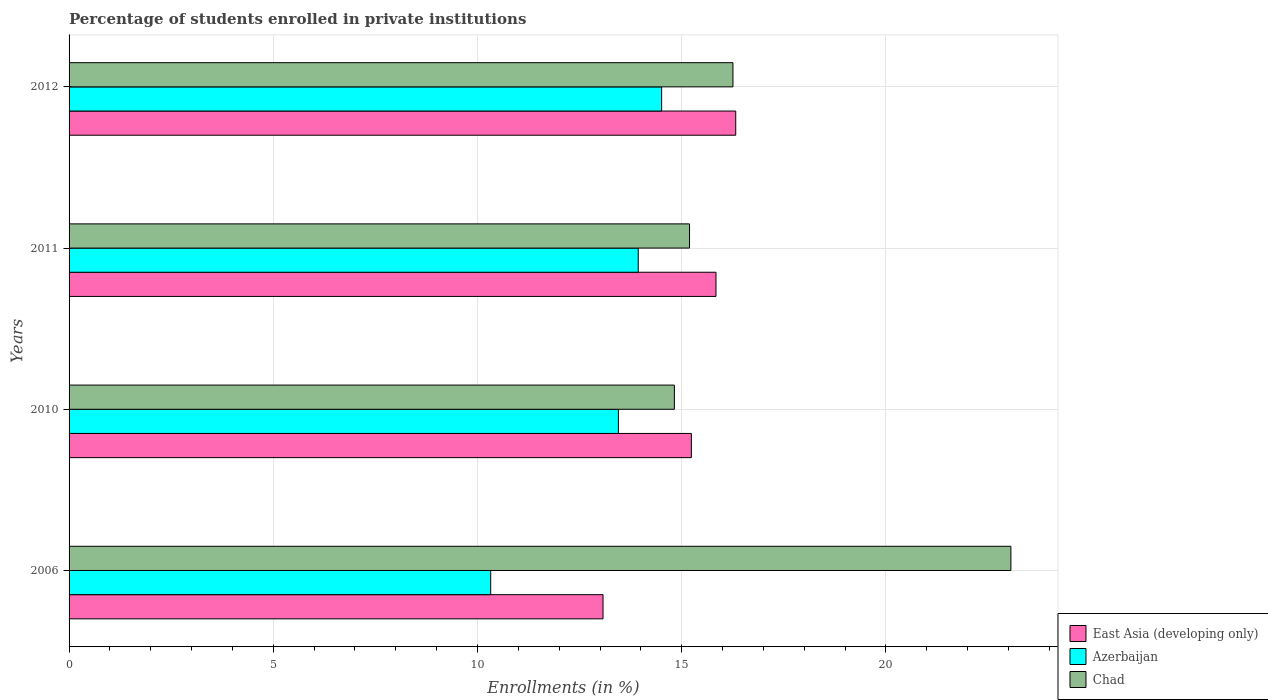How many different coloured bars are there?
Ensure brevity in your answer.  3. How many groups of bars are there?
Keep it short and to the point. 4. How many bars are there on the 2nd tick from the top?
Keep it short and to the point. 3. How many bars are there on the 2nd tick from the bottom?
Offer a terse response. 3. In how many cases, is the number of bars for a given year not equal to the number of legend labels?
Provide a short and direct response. 0. What is the percentage of trained teachers in Chad in 2010?
Provide a succinct answer. 14.82. Across all years, what is the maximum percentage of trained teachers in Azerbaijan?
Keep it short and to the point. 14.51. Across all years, what is the minimum percentage of trained teachers in East Asia (developing only)?
Your response must be concise. 13.07. In which year was the percentage of trained teachers in Azerbaijan maximum?
Offer a terse response. 2012. What is the total percentage of trained teachers in Chad in the graph?
Your response must be concise. 69.33. What is the difference between the percentage of trained teachers in Chad in 2011 and that in 2012?
Make the answer very short. -1.06. What is the difference between the percentage of trained teachers in East Asia (developing only) in 2006 and the percentage of trained teachers in Azerbaijan in 2011?
Provide a short and direct response. -0.86. What is the average percentage of trained teachers in Azerbaijan per year?
Provide a succinct answer. 13.05. In the year 2010, what is the difference between the percentage of trained teachers in Azerbaijan and percentage of trained teachers in Chad?
Make the answer very short. -1.37. In how many years, is the percentage of trained teachers in East Asia (developing only) greater than 20 %?
Your response must be concise. 0. What is the ratio of the percentage of trained teachers in East Asia (developing only) in 2006 to that in 2012?
Ensure brevity in your answer.  0.8. Is the percentage of trained teachers in East Asia (developing only) in 2010 less than that in 2012?
Give a very brief answer. Yes. What is the difference between the highest and the second highest percentage of trained teachers in East Asia (developing only)?
Your answer should be compact. 0.48. What is the difference between the highest and the lowest percentage of trained teachers in East Asia (developing only)?
Give a very brief answer. 3.25. What does the 3rd bar from the top in 2011 represents?
Your response must be concise. East Asia (developing only). What does the 3rd bar from the bottom in 2012 represents?
Your response must be concise. Chad. Is it the case that in every year, the sum of the percentage of trained teachers in Azerbaijan and percentage of trained teachers in East Asia (developing only) is greater than the percentage of trained teachers in Chad?
Your answer should be compact. Yes. Are all the bars in the graph horizontal?
Your answer should be compact. Yes. How many years are there in the graph?
Give a very brief answer. 4. Are the values on the major ticks of X-axis written in scientific E-notation?
Provide a succinct answer. No. Does the graph contain grids?
Your response must be concise. Yes. Where does the legend appear in the graph?
Give a very brief answer. Bottom right. How many legend labels are there?
Your answer should be very brief. 3. How are the legend labels stacked?
Your response must be concise. Vertical. What is the title of the graph?
Your answer should be very brief. Percentage of students enrolled in private institutions. Does "Congo (Democratic)" appear as one of the legend labels in the graph?
Offer a terse response. No. What is the label or title of the X-axis?
Your answer should be very brief. Enrollments (in %). What is the label or title of the Y-axis?
Provide a short and direct response. Years. What is the Enrollments (in %) in East Asia (developing only) in 2006?
Offer a terse response. 13.07. What is the Enrollments (in %) of Azerbaijan in 2006?
Give a very brief answer. 10.32. What is the Enrollments (in %) in Chad in 2006?
Your response must be concise. 23.06. What is the Enrollments (in %) in East Asia (developing only) in 2010?
Your answer should be compact. 15.24. What is the Enrollments (in %) in Azerbaijan in 2010?
Provide a short and direct response. 13.45. What is the Enrollments (in %) in Chad in 2010?
Ensure brevity in your answer.  14.82. What is the Enrollments (in %) of East Asia (developing only) in 2011?
Ensure brevity in your answer.  15.84. What is the Enrollments (in %) in Azerbaijan in 2011?
Offer a terse response. 13.94. What is the Enrollments (in %) of Chad in 2011?
Give a very brief answer. 15.19. What is the Enrollments (in %) in East Asia (developing only) in 2012?
Provide a succinct answer. 16.32. What is the Enrollments (in %) of Azerbaijan in 2012?
Provide a succinct answer. 14.51. What is the Enrollments (in %) in Chad in 2012?
Ensure brevity in your answer.  16.26. Across all years, what is the maximum Enrollments (in %) in East Asia (developing only)?
Provide a short and direct response. 16.32. Across all years, what is the maximum Enrollments (in %) of Azerbaijan?
Give a very brief answer. 14.51. Across all years, what is the maximum Enrollments (in %) in Chad?
Ensure brevity in your answer.  23.06. Across all years, what is the minimum Enrollments (in %) in East Asia (developing only)?
Offer a terse response. 13.07. Across all years, what is the minimum Enrollments (in %) of Azerbaijan?
Ensure brevity in your answer.  10.32. Across all years, what is the minimum Enrollments (in %) of Chad?
Keep it short and to the point. 14.82. What is the total Enrollments (in %) in East Asia (developing only) in the graph?
Ensure brevity in your answer.  60.47. What is the total Enrollments (in %) in Azerbaijan in the graph?
Your answer should be compact. 52.22. What is the total Enrollments (in %) in Chad in the graph?
Offer a very short reply. 69.33. What is the difference between the Enrollments (in %) in East Asia (developing only) in 2006 and that in 2010?
Ensure brevity in your answer.  -2.16. What is the difference between the Enrollments (in %) of Azerbaijan in 2006 and that in 2010?
Your answer should be very brief. -3.13. What is the difference between the Enrollments (in %) in Chad in 2006 and that in 2010?
Your answer should be very brief. 8.24. What is the difference between the Enrollments (in %) in East Asia (developing only) in 2006 and that in 2011?
Your answer should be compact. -2.77. What is the difference between the Enrollments (in %) in Azerbaijan in 2006 and that in 2011?
Your answer should be compact. -3.61. What is the difference between the Enrollments (in %) in Chad in 2006 and that in 2011?
Offer a terse response. 7.87. What is the difference between the Enrollments (in %) of East Asia (developing only) in 2006 and that in 2012?
Your response must be concise. -3.25. What is the difference between the Enrollments (in %) of Azerbaijan in 2006 and that in 2012?
Your answer should be very brief. -4.18. What is the difference between the Enrollments (in %) in Chad in 2006 and that in 2012?
Your answer should be very brief. 6.8. What is the difference between the Enrollments (in %) in East Asia (developing only) in 2010 and that in 2011?
Provide a short and direct response. -0.6. What is the difference between the Enrollments (in %) of Azerbaijan in 2010 and that in 2011?
Provide a short and direct response. -0.49. What is the difference between the Enrollments (in %) of Chad in 2010 and that in 2011?
Provide a short and direct response. -0.37. What is the difference between the Enrollments (in %) in East Asia (developing only) in 2010 and that in 2012?
Your answer should be compact. -1.09. What is the difference between the Enrollments (in %) in Azerbaijan in 2010 and that in 2012?
Your response must be concise. -1.06. What is the difference between the Enrollments (in %) in Chad in 2010 and that in 2012?
Make the answer very short. -1.43. What is the difference between the Enrollments (in %) of East Asia (developing only) in 2011 and that in 2012?
Your response must be concise. -0.48. What is the difference between the Enrollments (in %) of Azerbaijan in 2011 and that in 2012?
Provide a short and direct response. -0.57. What is the difference between the Enrollments (in %) of Chad in 2011 and that in 2012?
Offer a terse response. -1.06. What is the difference between the Enrollments (in %) of East Asia (developing only) in 2006 and the Enrollments (in %) of Azerbaijan in 2010?
Your answer should be compact. -0.38. What is the difference between the Enrollments (in %) of East Asia (developing only) in 2006 and the Enrollments (in %) of Chad in 2010?
Provide a succinct answer. -1.75. What is the difference between the Enrollments (in %) of Azerbaijan in 2006 and the Enrollments (in %) of Chad in 2010?
Keep it short and to the point. -4.5. What is the difference between the Enrollments (in %) of East Asia (developing only) in 2006 and the Enrollments (in %) of Azerbaijan in 2011?
Your answer should be very brief. -0.86. What is the difference between the Enrollments (in %) of East Asia (developing only) in 2006 and the Enrollments (in %) of Chad in 2011?
Offer a very short reply. -2.12. What is the difference between the Enrollments (in %) of Azerbaijan in 2006 and the Enrollments (in %) of Chad in 2011?
Offer a terse response. -4.87. What is the difference between the Enrollments (in %) of East Asia (developing only) in 2006 and the Enrollments (in %) of Azerbaijan in 2012?
Provide a short and direct response. -1.43. What is the difference between the Enrollments (in %) in East Asia (developing only) in 2006 and the Enrollments (in %) in Chad in 2012?
Ensure brevity in your answer.  -3.18. What is the difference between the Enrollments (in %) in Azerbaijan in 2006 and the Enrollments (in %) in Chad in 2012?
Ensure brevity in your answer.  -5.93. What is the difference between the Enrollments (in %) in East Asia (developing only) in 2010 and the Enrollments (in %) in Azerbaijan in 2011?
Keep it short and to the point. 1.3. What is the difference between the Enrollments (in %) of East Asia (developing only) in 2010 and the Enrollments (in %) of Chad in 2011?
Your response must be concise. 0.04. What is the difference between the Enrollments (in %) in Azerbaijan in 2010 and the Enrollments (in %) in Chad in 2011?
Provide a short and direct response. -1.74. What is the difference between the Enrollments (in %) in East Asia (developing only) in 2010 and the Enrollments (in %) in Azerbaijan in 2012?
Keep it short and to the point. 0.73. What is the difference between the Enrollments (in %) in East Asia (developing only) in 2010 and the Enrollments (in %) in Chad in 2012?
Your response must be concise. -1.02. What is the difference between the Enrollments (in %) in Azerbaijan in 2010 and the Enrollments (in %) in Chad in 2012?
Ensure brevity in your answer.  -2.81. What is the difference between the Enrollments (in %) in East Asia (developing only) in 2011 and the Enrollments (in %) in Azerbaijan in 2012?
Your answer should be compact. 1.33. What is the difference between the Enrollments (in %) in East Asia (developing only) in 2011 and the Enrollments (in %) in Chad in 2012?
Provide a succinct answer. -0.42. What is the difference between the Enrollments (in %) in Azerbaijan in 2011 and the Enrollments (in %) in Chad in 2012?
Make the answer very short. -2.32. What is the average Enrollments (in %) of East Asia (developing only) per year?
Your response must be concise. 15.12. What is the average Enrollments (in %) in Azerbaijan per year?
Give a very brief answer. 13.05. What is the average Enrollments (in %) in Chad per year?
Provide a succinct answer. 17.33. In the year 2006, what is the difference between the Enrollments (in %) of East Asia (developing only) and Enrollments (in %) of Azerbaijan?
Give a very brief answer. 2.75. In the year 2006, what is the difference between the Enrollments (in %) in East Asia (developing only) and Enrollments (in %) in Chad?
Offer a very short reply. -9.99. In the year 2006, what is the difference between the Enrollments (in %) in Azerbaijan and Enrollments (in %) in Chad?
Offer a very short reply. -12.74. In the year 2010, what is the difference between the Enrollments (in %) in East Asia (developing only) and Enrollments (in %) in Azerbaijan?
Offer a very short reply. 1.79. In the year 2010, what is the difference between the Enrollments (in %) in East Asia (developing only) and Enrollments (in %) in Chad?
Provide a short and direct response. 0.42. In the year 2010, what is the difference between the Enrollments (in %) of Azerbaijan and Enrollments (in %) of Chad?
Offer a very short reply. -1.37. In the year 2011, what is the difference between the Enrollments (in %) in East Asia (developing only) and Enrollments (in %) in Azerbaijan?
Ensure brevity in your answer.  1.9. In the year 2011, what is the difference between the Enrollments (in %) in East Asia (developing only) and Enrollments (in %) in Chad?
Keep it short and to the point. 0.65. In the year 2011, what is the difference between the Enrollments (in %) of Azerbaijan and Enrollments (in %) of Chad?
Offer a terse response. -1.26. In the year 2012, what is the difference between the Enrollments (in %) of East Asia (developing only) and Enrollments (in %) of Azerbaijan?
Give a very brief answer. 1.81. In the year 2012, what is the difference between the Enrollments (in %) in East Asia (developing only) and Enrollments (in %) in Chad?
Keep it short and to the point. 0.07. In the year 2012, what is the difference between the Enrollments (in %) of Azerbaijan and Enrollments (in %) of Chad?
Keep it short and to the point. -1.75. What is the ratio of the Enrollments (in %) in East Asia (developing only) in 2006 to that in 2010?
Ensure brevity in your answer.  0.86. What is the ratio of the Enrollments (in %) in Azerbaijan in 2006 to that in 2010?
Offer a terse response. 0.77. What is the ratio of the Enrollments (in %) in Chad in 2006 to that in 2010?
Make the answer very short. 1.56. What is the ratio of the Enrollments (in %) in East Asia (developing only) in 2006 to that in 2011?
Offer a very short reply. 0.83. What is the ratio of the Enrollments (in %) in Azerbaijan in 2006 to that in 2011?
Offer a very short reply. 0.74. What is the ratio of the Enrollments (in %) in Chad in 2006 to that in 2011?
Offer a terse response. 1.52. What is the ratio of the Enrollments (in %) of East Asia (developing only) in 2006 to that in 2012?
Your answer should be very brief. 0.8. What is the ratio of the Enrollments (in %) in Azerbaijan in 2006 to that in 2012?
Keep it short and to the point. 0.71. What is the ratio of the Enrollments (in %) of Chad in 2006 to that in 2012?
Provide a succinct answer. 1.42. What is the ratio of the Enrollments (in %) of East Asia (developing only) in 2010 to that in 2011?
Give a very brief answer. 0.96. What is the ratio of the Enrollments (in %) of Azerbaijan in 2010 to that in 2011?
Make the answer very short. 0.97. What is the ratio of the Enrollments (in %) in Chad in 2010 to that in 2011?
Your response must be concise. 0.98. What is the ratio of the Enrollments (in %) of East Asia (developing only) in 2010 to that in 2012?
Ensure brevity in your answer.  0.93. What is the ratio of the Enrollments (in %) of Azerbaijan in 2010 to that in 2012?
Your answer should be very brief. 0.93. What is the ratio of the Enrollments (in %) of Chad in 2010 to that in 2012?
Give a very brief answer. 0.91. What is the ratio of the Enrollments (in %) of East Asia (developing only) in 2011 to that in 2012?
Offer a very short reply. 0.97. What is the ratio of the Enrollments (in %) in Azerbaijan in 2011 to that in 2012?
Offer a very short reply. 0.96. What is the ratio of the Enrollments (in %) in Chad in 2011 to that in 2012?
Offer a terse response. 0.93. What is the difference between the highest and the second highest Enrollments (in %) of East Asia (developing only)?
Make the answer very short. 0.48. What is the difference between the highest and the second highest Enrollments (in %) of Azerbaijan?
Your answer should be very brief. 0.57. What is the difference between the highest and the second highest Enrollments (in %) in Chad?
Provide a short and direct response. 6.8. What is the difference between the highest and the lowest Enrollments (in %) of East Asia (developing only)?
Your answer should be very brief. 3.25. What is the difference between the highest and the lowest Enrollments (in %) of Azerbaijan?
Your answer should be very brief. 4.18. What is the difference between the highest and the lowest Enrollments (in %) in Chad?
Keep it short and to the point. 8.24. 